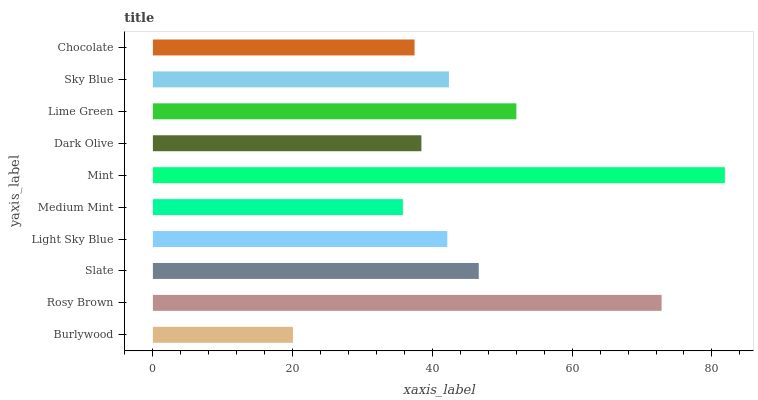Is Burlywood the minimum?
Answer yes or no. Yes. Is Mint the maximum?
Answer yes or no. Yes. Is Rosy Brown the minimum?
Answer yes or no. No. Is Rosy Brown the maximum?
Answer yes or no. No. Is Rosy Brown greater than Burlywood?
Answer yes or no. Yes. Is Burlywood less than Rosy Brown?
Answer yes or no. Yes. Is Burlywood greater than Rosy Brown?
Answer yes or no. No. Is Rosy Brown less than Burlywood?
Answer yes or no. No. Is Sky Blue the high median?
Answer yes or no. Yes. Is Light Sky Blue the low median?
Answer yes or no. Yes. Is Slate the high median?
Answer yes or no. No. Is Rosy Brown the low median?
Answer yes or no. No. 